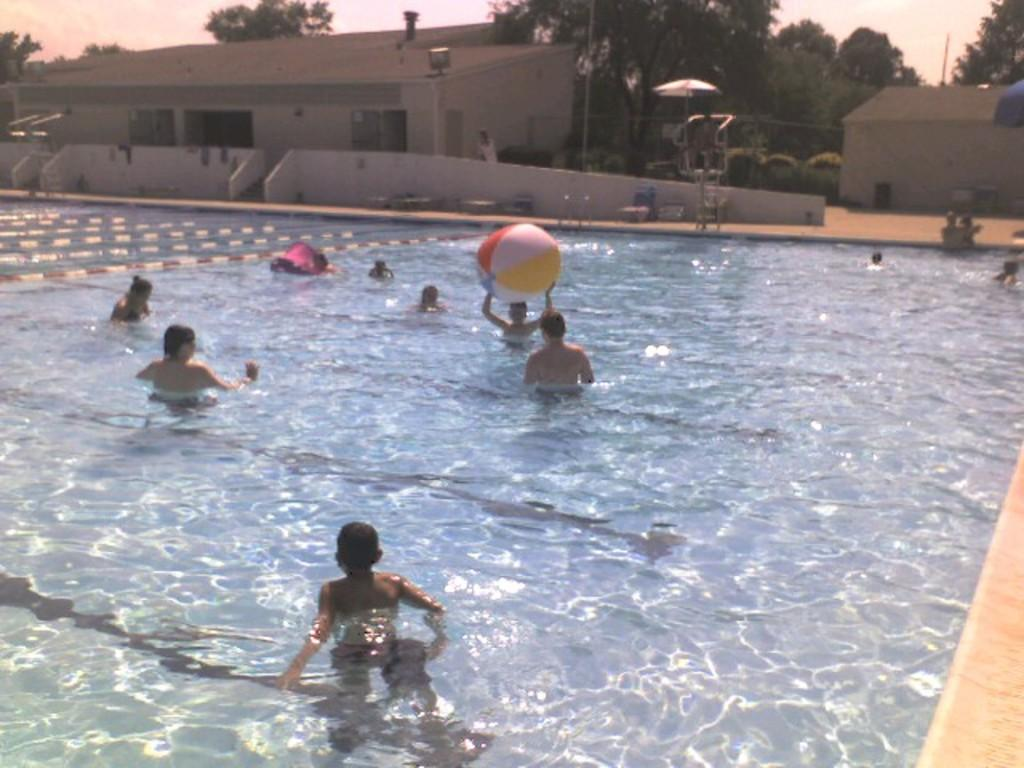What are the people in the image doing? The people in the image are in the water. What can be seen in the background of the image? There are buildings, trees, and the sky visible in the background of the image. What type of cord is being used by the people in the water? There is no cord present in the image; the people are simply in the water. 